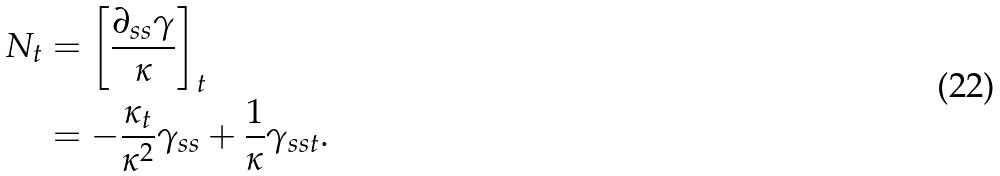<formula> <loc_0><loc_0><loc_500><loc_500>N _ { t } & = \left [ \frac { \partial _ { s s } \gamma } { \kappa } \right ] _ { t } \\ & = - \frac { \kappa _ { t } } { \kappa ^ { 2 } } \gamma _ { s s } + \frac { 1 } { \kappa } \gamma _ { s s t } .</formula> 